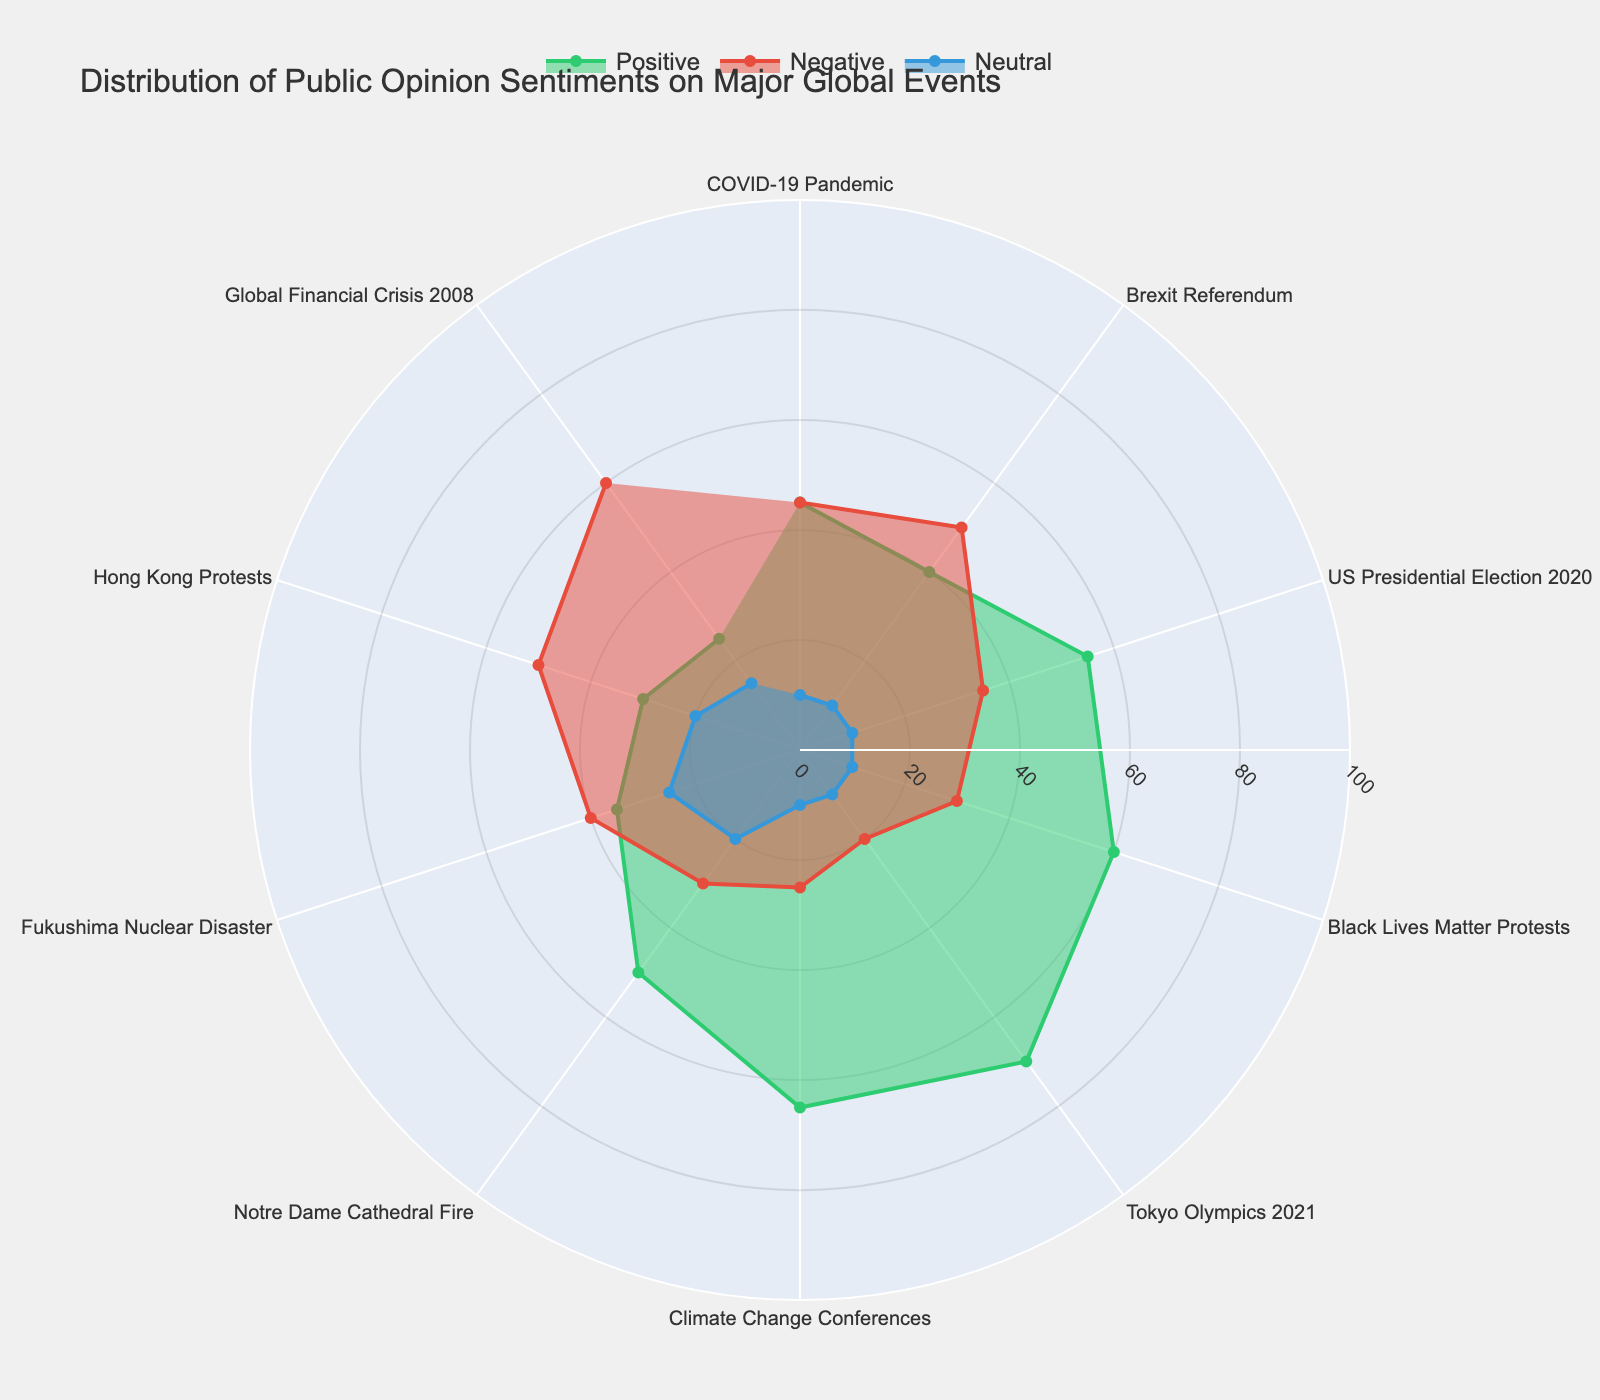How many events are listed in the radar chart? By counting the unique categories (events) in the figure, the total number can be determined.
Answer: 10 Which global event has the highest percentage of positive sentiment? By examining the 'Positive' data points in the radar chart, the event with the maximum positive sentiment can be identified.
Answer: Tokyo Olympics 2021 Which sentiment category has the most even distribution across all events? Assess the radar chart sections for each sentiment category and determine which one generally has similar values for all events.
Answer: Neutral What is the combined positive sentiment for Brexit Referendum and US Presidential Election 2020? Sum the 'Positive' percentages for Brexit Referendum (40) and US Presidential Election 2020 (55).
Answer: 95 For which event is the negative sentiment the highest? Identify the event with the maximum value in the 'Negative' section of the radar chart.
Answer: Global Financial Crisis 2008 Compare the negative sentiment between the COVID-19 Pandemic and Fukushima Nuclear Disaster. Check the 'Negative' values for both events, which are 45 and 40 respectively, and compare them.
Answer: COVID-19 Pandemic has a higher negative sentiment What is the difference in neutral sentiment between Notre Dame Cathedral Fire and Hong Kong Protests? Subtract the 'Neutral' sentiment of Notre Dame Cathedral Fire (20) from that of Hong Kong Protests (20).
Answer: 0 Which sentiment category for Black Lives Matter Protests is twice as much as its neutral sentiment? Compare each sentiment category values (Positive: 60, Negative: 30, Neutral: 10) for Black Lives Matter Protests.
Answer: Positive What is the average neutral sentiment across all events? Sum all 'Neutral' sentiments (10+10+10+10+10+10+20+25+20+15=140) and divide by the number of events (10).
Answer: 14 Compare the total positive and negative sentiments for Climate Change Conferences. Which is higher? Positive sentiment is 65, and negative sentiment is 25 for Climate Change Conferences.
Answer: Positive 